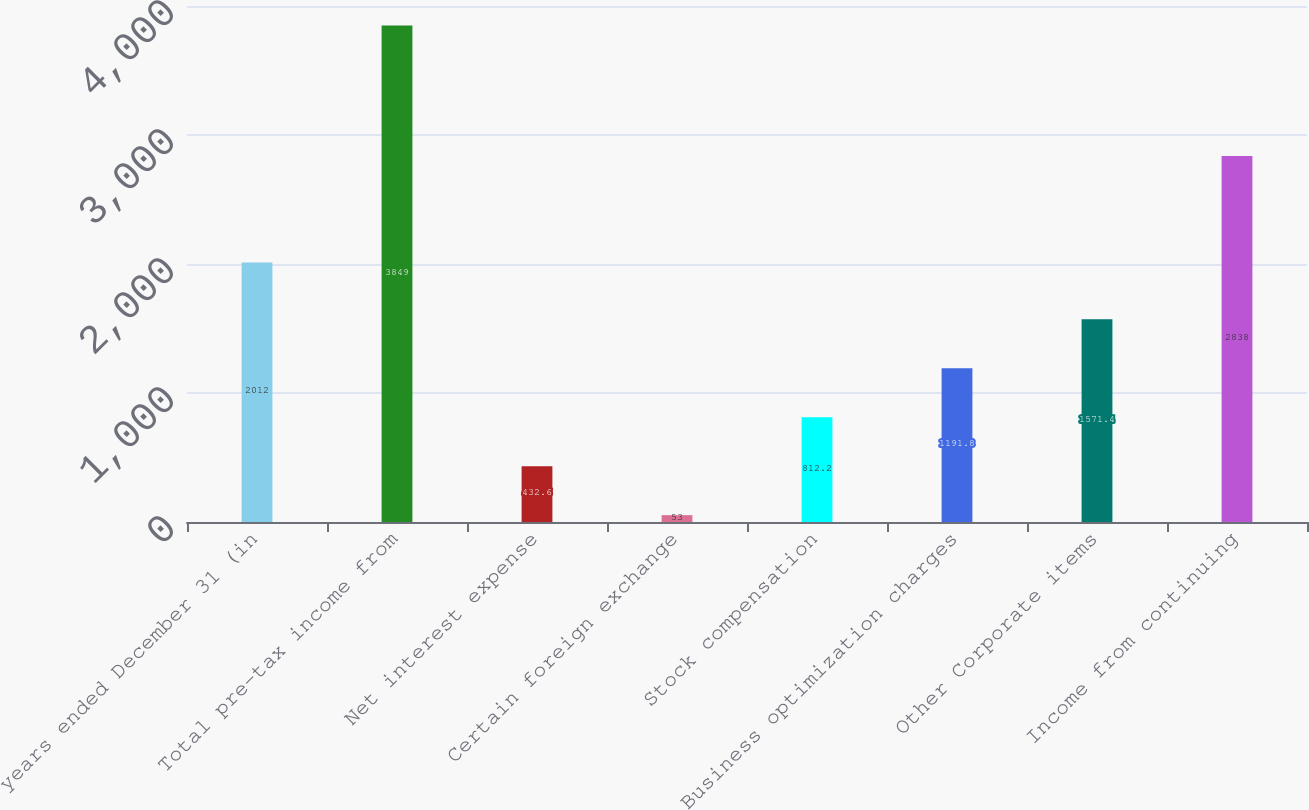Convert chart. <chart><loc_0><loc_0><loc_500><loc_500><bar_chart><fcel>years ended December 31 (in<fcel>Total pre-tax income from<fcel>Net interest expense<fcel>Certain foreign exchange<fcel>Stock compensation<fcel>Business optimization charges<fcel>Other Corporate items<fcel>Income from continuing<nl><fcel>2012<fcel>3849<fcel>432.6<fcel>53<fcel>812.2<fcel>1191.8<fcel>1571.4<fcel>2838<nl></chart> 